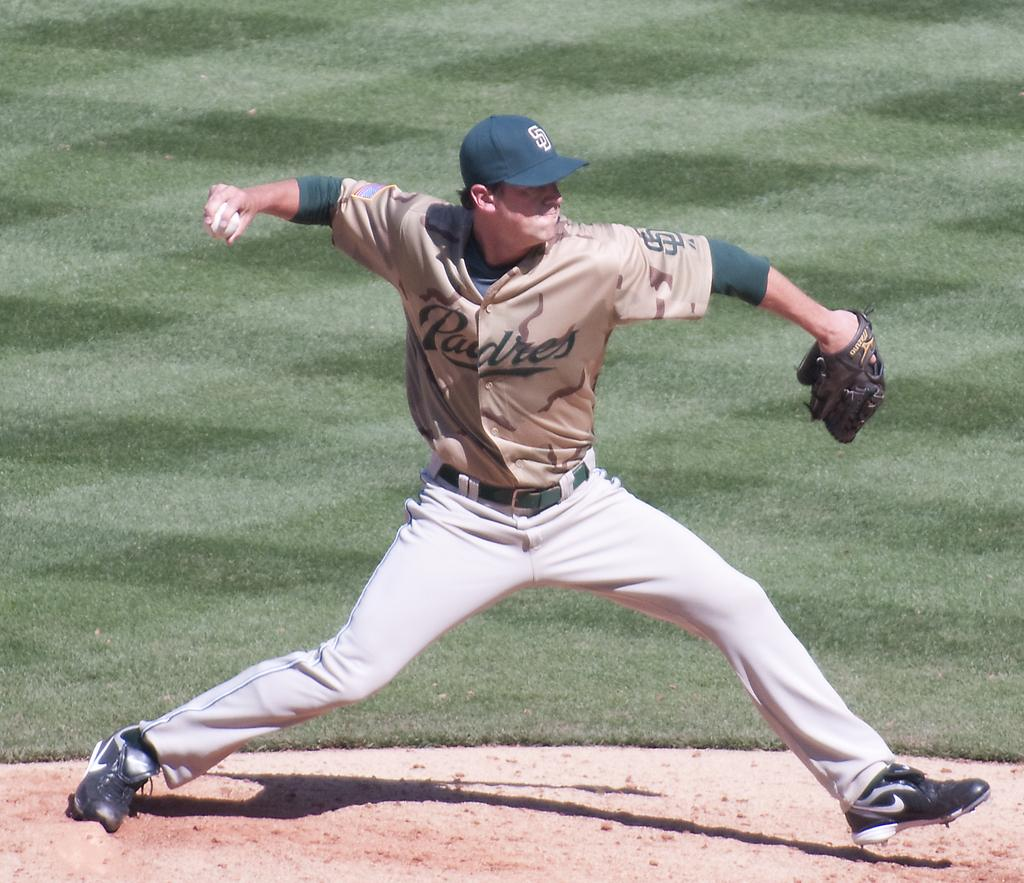What is the main subject of the image? There is a person in the image. What is the person wearing on their hands? The person is wearing gloves. What is the person wearing on their head? The person is wearing a cap. What action is the person performing in the image? The person is trying to throw a ball. Where is the person located in the image? The person is on the ground. What type of vegetation can be seen in the background of the image? There is grass visible in the background of the image. What type of shoe is the person wearing in the image? There is no shoe visible in the image; the person is on the ground. How many socks can be seen on the person's feet in the image? There is no sock visible in the image; the person is wearing gloves on their hands. 